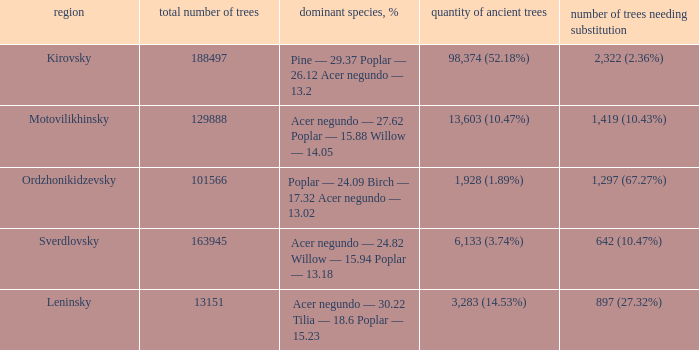What is the total amount of trees when district is leninsky? 13151.0. 